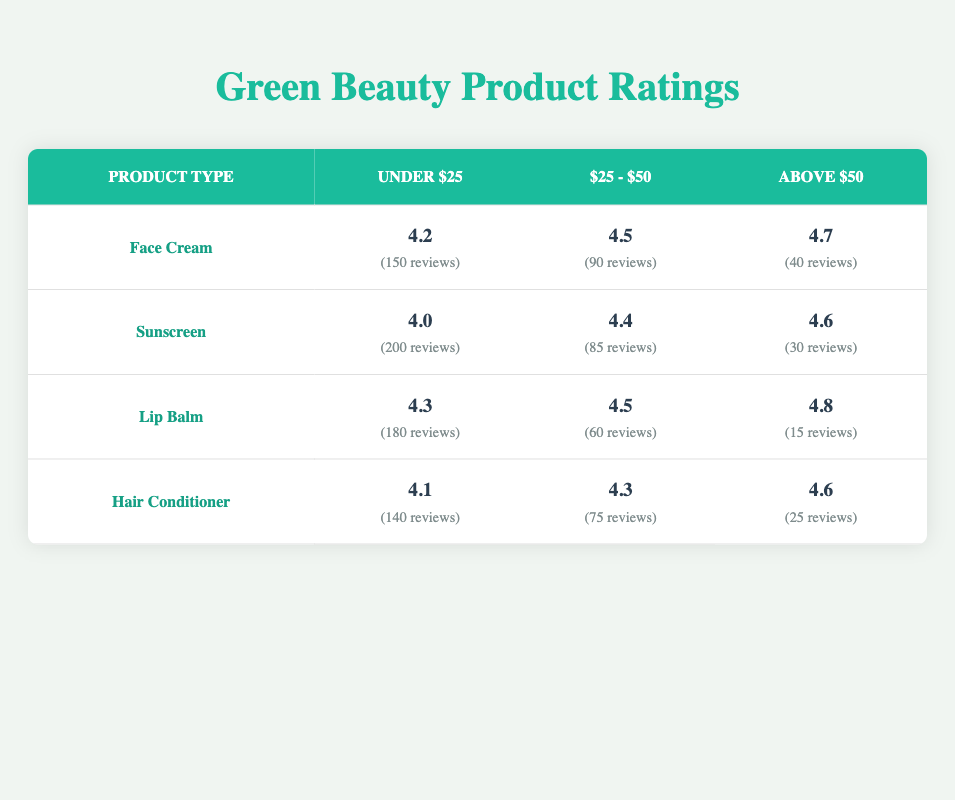What is the average rating for Face Cream in the price range of Under $25? The table shows that the average rating for Face Cream in the Under $25 price range is 4.2. This information is directly retrievable from the respective row and column of the table.
Answer: 4.2 Which product type has the highest average rating in the Above $50 price range? By evaluating the ratings in the Above $50 column, Face Cream has an average rating of 4.7, Sunscreen has 4.6, Lip Balm has 4.8, and Hair Conditioner has 4.6. Lip Balm has the highest rating of 4.8.
Answer: Lip Balm Is there a product type that consistently has a rating above 4.4 in all price ranges? The table shows that for Face Cream, the ratings are 4.2, 4.5, and 4.7; for Sunscreen, they are 4.0, 4.4, and 4.6; for Lip Balm, the ratings are 4.3, 4.5, and 4.8; and for Hair Conditioner, the ratings are 4.1, 4.3, and 4.6. None of the product types consistently have a rating above 4.4 across all price ranges.
Answer: No What is the total number of reviews for Lip Balm across all price ranges? The number of reviews for Lip Balm in the Under $25 is 180, for $25 - $50 is 60, and for Above $50 is 15. Adding these values (180 + 60 + 15) gives a total of 255 reviews for Lip Balm.
Answer: 255 Which price range has the highest average rating across all product types? The Under $25 price range has average ratings of 4.2, 4.0, 4.3, and 4.1, which average to (4.2 + 4.0 + 4.3 + 4.1)/4 = 4.165. The $25 - $50 range has average ratings of 4.5, 4.4, 4.5, and 4.3, averaging to (4.5 + 4.4 + 4.5 + 4.3)/4 = 4.425, while the Above $50 range has average ratings of 4.7, 4.6, 4.8, and 4.6, averaging to (4.7 + 4.6 + 4.8 + 4.6)/4 = 4.675. Thus, the Above $50 range has the highest average rating.
Answer: Above $50 